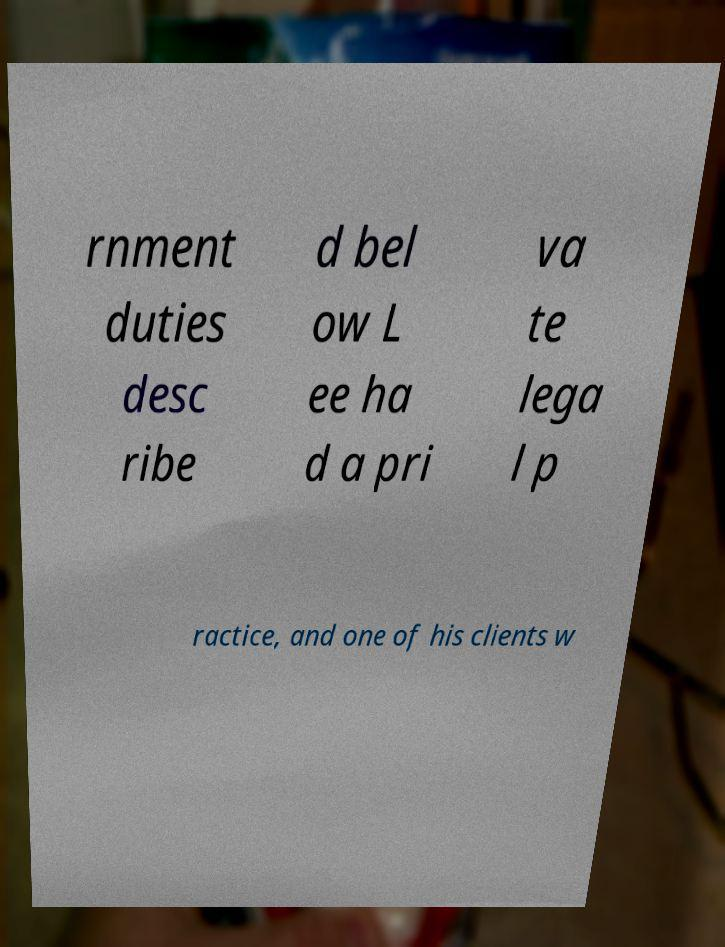For documentation purposes, I need the text within this image transcribed. Could you provide that? rnment duties desc ribe d bel ow L ee ha d a pri va te lega l p ractice, and one of his clients w 